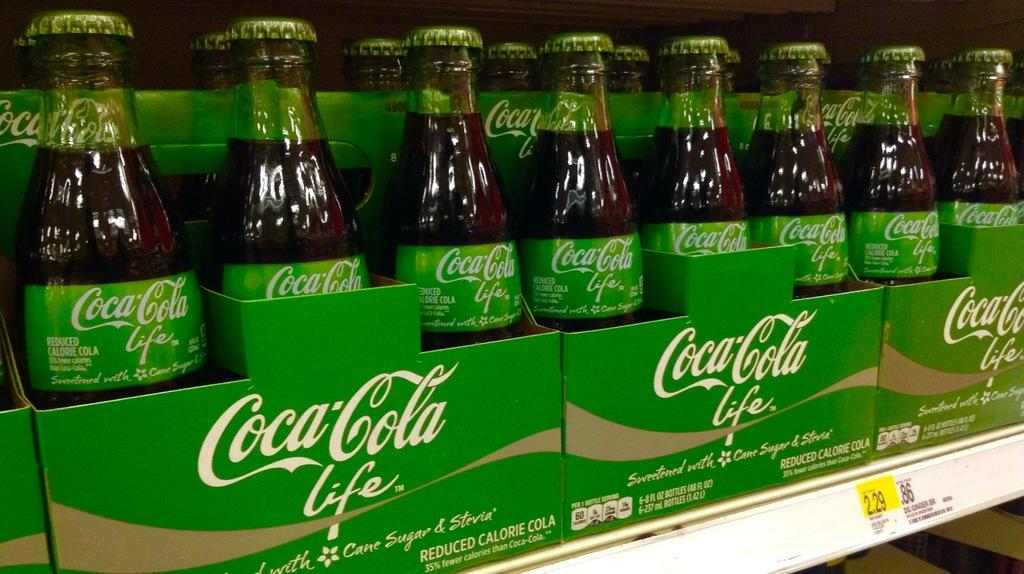What type of objects can be seen in the image? There are bottles and cardboards in the image. What colors are the bottles? The bottles are green and black in color. What is written on the cardboards? The cardboards have "Coca Cola Life" written on them. How many trails can be seen in the image? There are no trails present in the image. What type of shock is depicted in the image? There is no shock depicted in the image. 